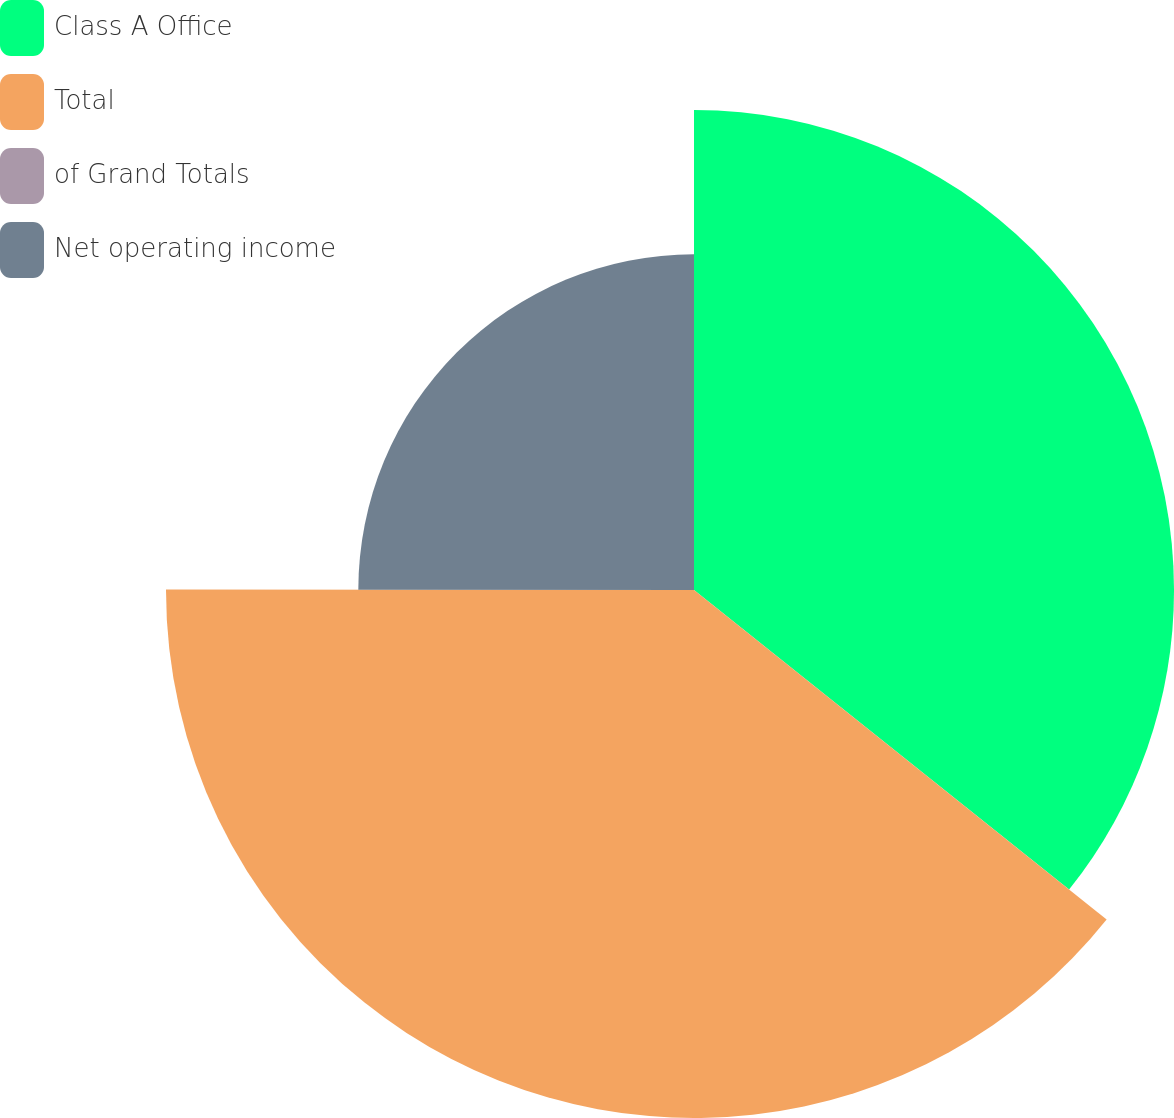Convert chart. <chart><loc_0><loc_0><loc_500><loc_500><pie_chart><fcel>Class A Office<fcel>Total<fcel>of Grand Totals<fcel>Net operating income<nl><fcel>35.72%<fcel>39.29%<fcel>0.0%<fcel>24.98%<nl></chart> 